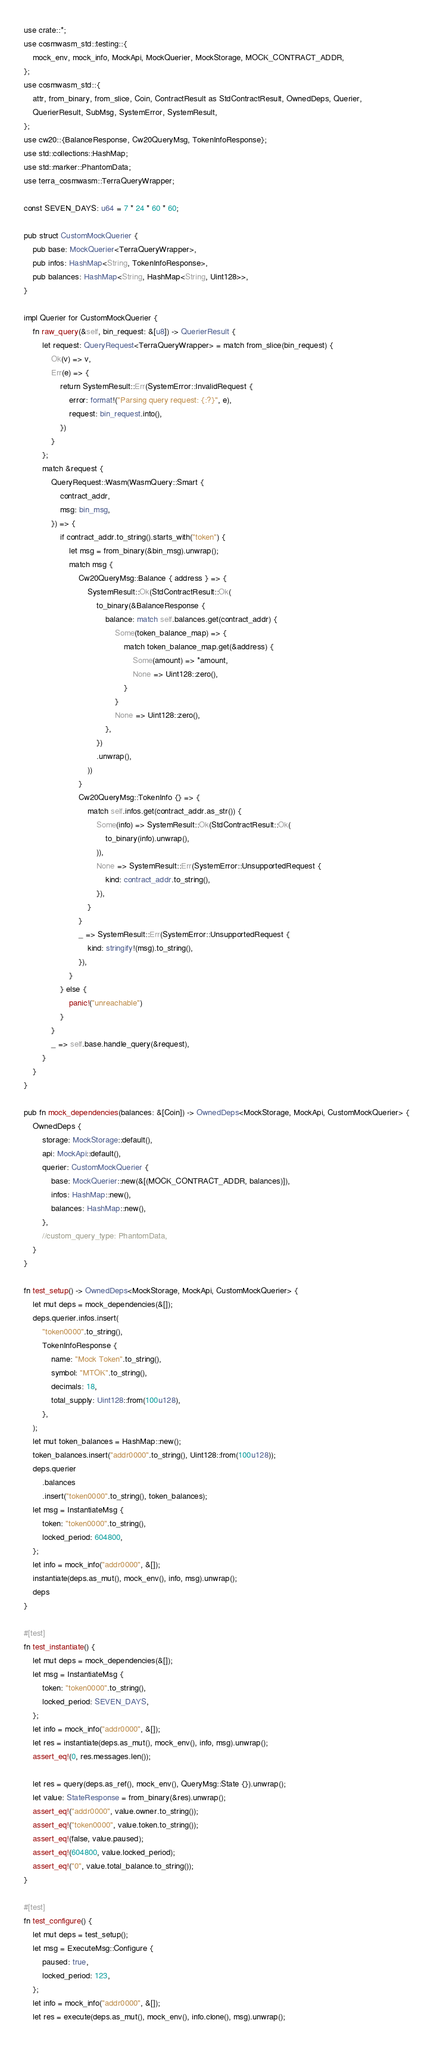Convert code to text. <code><loc_0><loc_0><loc_500><loc_500><_Rust_>use crate::*;
use cosmwasm_std::testing::{
    mock_env, mock_info, MockApi, MockQuerier, MockStorage, MOCK_CONTRACT_ADDR,
};
use cosmwasm_std::{
    attr, from_binary, from_slice, Coin, ContractResult as StdContractResult, OwnedDeps, Querier,
    QuerierResult, SubMsg, SystemError, SystemResult,
};
use cw20::{BalanceResponse, Cw20QueryMsg, TokenInfoResponse};
use std::collections::HashMap;
use std::marker::PhantomData;
use terra_cosmwasm::TerraQueryWrapper;

const SEVEN_DAYS: u64 = 7 * 24 * 60 * 60;

pub struct CustomMockQuerier {
    pub base: MockQuerier<TerraQueryWrapper>,
    pub infos: HashMap<String, TokenInfoResponse>,
    pub balances: HashMap<String, HashMap<String, Uint128>>,
}

impl Querier for CustomMockQuerier {
    fn raw_query(&self, bin_request: &[u8]) -> QuerierResult {
        let request: QueryRequest<TerraQueryWrapper> = match from_slice(bin_request) {
            Ok(v) => v,
            Err(e) => {
                return SystemResult::Err(SystemError::InvalidRequest {
                    error: format!("Parsing query request: {:?}", e),
                    request: bin_request.into(),
                })
            }
        };
        match &request {
            QueryRequest::Wasm(WasmQuery::Smart {
                contract_addr,
                msg: bin_msg,
            }) => {
                if contract_addr.to_string().starts_with("token") {
                    let msg = from_binary(&bin_msg).unwrap();
                    match msg {
                        Cw20QueryMsg::Balance { address } => {
                            SystemResult::Ok(StdContractResult::Ok(
                                to_binary(&BalanceResponse {
                                    balance: match self.balances.get(contract_addr) {
                                        Some(token_balance_map) => {
                                            match token_balance_map.get(&address) {
                                                Some(amount) => *amount,
                                                None => Uint128::zero(),
                                            }
                                        }
                                        None => Uint128::zero(),
                                    },
                                })
                                .unwrap(),
                            ))
                        }
                        Cw20QueryMsg::TokenInfo {} => {
                            match self.infos.get(contract_addr.as_str()) {
                                Some(info) => SystemResult::Ok(StdContractResult::Ok(
                                    to_binary(info).unwrap(),
                                )),
                                None => SystemResult::Err(SystemError::UnsupportedRequest {
                                    kind: contract_addr.to_string(),
                                }),
                            }
                        }
                        _ => SystemResult::Err(SystemError::UnsupportedRequest {
                            kind: stringify!(msg).to_string(),
                        }),
                    }
                } else {
                    panic!("unreachable")
                }
            }
            _ => self.base.handle_query(&request),
        }
    }
}

pub fn mock_dependencies(balances: &[Coin]) -> OwnedDeps<MockStorage, MockApi, CustomMockQuerier> {
    OwnedDeps {
        storage: MockStorage::default(),
        api: MockApi::default(),
        querier: CustomMockQuerier {
            base: MockQuerier::new(&[(MOCK_CONTRACT_ADDR, balances)]),
            infos: HashMap::new(),
            balances: HashMap::new(),
        },
        //custom_query_type: PhantomData,
    }
}

fn test_setup() -> OwnedDeps<MockStorage, MockApi, CustomMockQuerier> {
    let mut deps = mock_dependencies(&[]);
    deps.querier.infos.insert(
        "token0000".to_string(),
        TokenInfoResponse {
            name: "Mock Token".to_string(),
            symbol: "MTOK".to_string(),
            decimals: 18,
            total_supply: Uint128::from(100u128),
        },
    );
    let mut token_balances = HashMap::new();
    token_balances.insert("addr0000".to_string(), Uint128::from(100u128));
    deps.querier
        .balances
        .insert("token0000".to_string(), token_balances);
    let msg = InstantiateMsg {
        token: "token0000".to_string(),
        locked_period: 604800,
    };
    let info = mock_info("addr0000", &[]);
    instantiate(deps.as_mut(), mock_env(), info, msg).unwrap();
    deps
}

#[test]
fn test_instantiate() {
    let mut deps = mock_dependencies(&[]);
    let msg = InstantiateMsg {
        token: "token0000".to_string(),
        locked_period: SEVEN_DAYS,
    };
    let info = mock_info("addr0000", &[]);
    let res = instantiate(deps.as_mut(), mock_env(), info, msg).unwrap();
    assert_eq!(0, res.messages.len());

    let res = query(deps.as_ref(), mock_env(), QueryMsg::State {}).unwrap();
    let value: StateResponse = from_binary(&res).unwrap();
    assert_eq!("addr0000", value.owner.to_string());
    assert_eq!("token0000", value.token.to_string());
    assert_eq!(false, value.paused);
    assert_eq!(604800, value.locked_period);
    assert_eq!("0", value.total_balance.to_string());
}

#[test]
fn test_configure() {
    let mut deps = test_setup();
    let msg = ExecuteMsg::Configure {
        paused: true,
        locked_period: 123,
    };
    let info = mock_info("addr0000", &[]);
    let res = execute(deps.as_mut(), mock_env(), info.clone(), msg).unwrap();</code> 